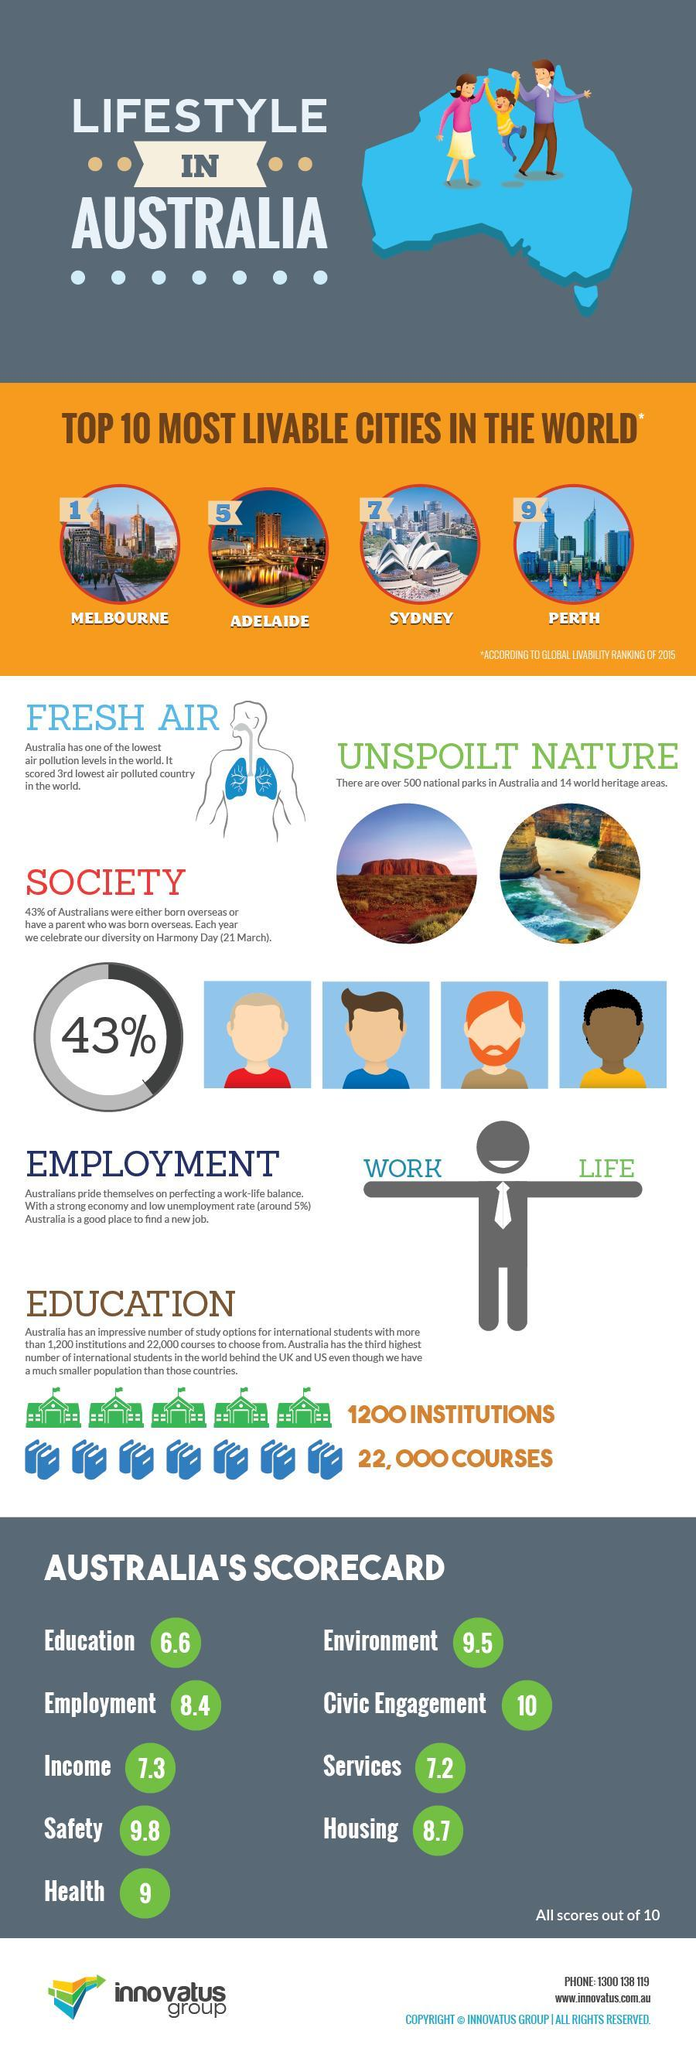Which is ninth most livable city in the world?
Answer the question with a short phrase. Perth Which country has the third lowest level of air pollution in the world? Australia 